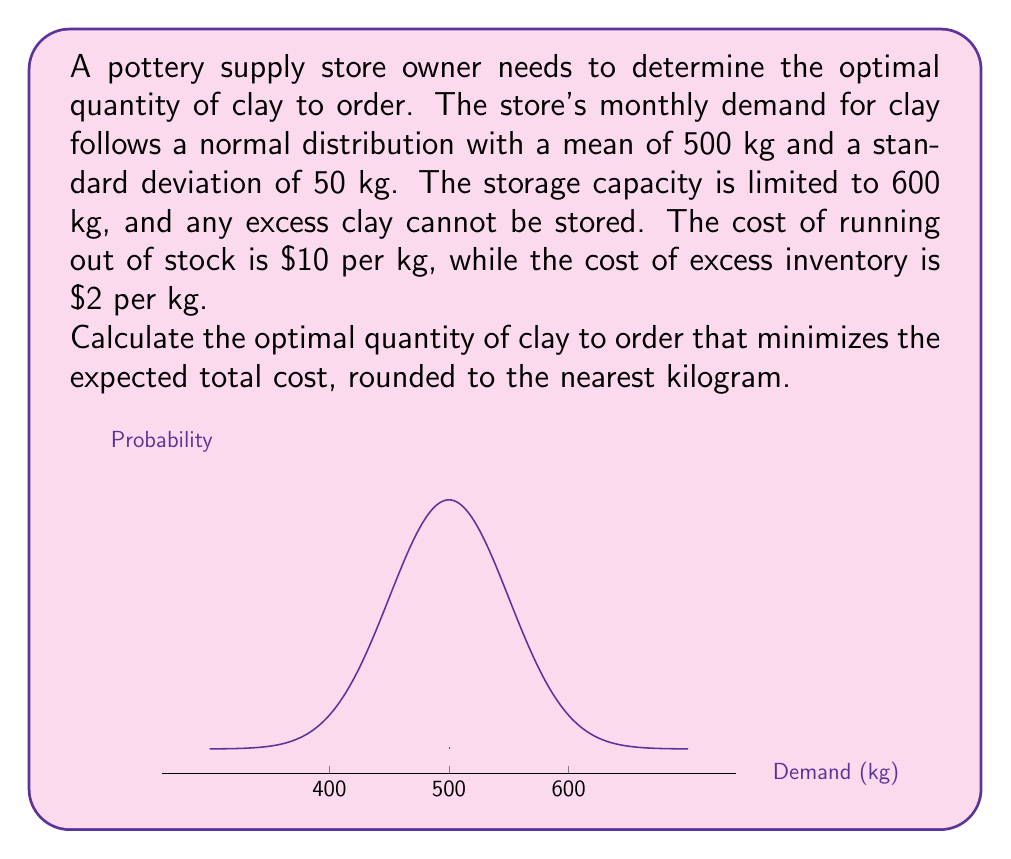Can you answer this question? To solve this problem, we need to use the concept of the critical fractile from inventory management theory. The critical fractile determines the optimal service level, which in turn helps us find the optimal order quantity.

Step 1: Calculate the critical fractile (CF)
$CF = \frac{C_u}{C_u + C_o}$
Where $C_u$ is the cost of understocking (running out) and $C_o$ is the cost of overstocking.

$CF = \frac{10}{10 + 2} = \frac{10}{12} \approx 0.8333$

Step 2: Find the z-score corresponding to the critical fractile
Using a standard normal distribution table or calculator, we find that the z-score for 0.8333 is approximately 0.97.

Step 3: Calculate the optimal order quantity (Q)
$Q = \mu + z\sigma$
Where $\mu$ is the mean demand and $\sigma$ is the standard deviation.

$Q = 500 + 0.97 \times 50 = 548.5$ kg

Step 4: Check if the optimal quantity exceeds storage capacity
Since 548.5 kg is less than the storage capacity of 600 kg, we don't need to adjust our calculation.

Step 5: Round to the nearest kilogram
548.5 kg rounded to the nearest kilogram is 549 kg.

Therefore, the optimal quantity of clay to order is 549 kg.
Answer: 549 kg 